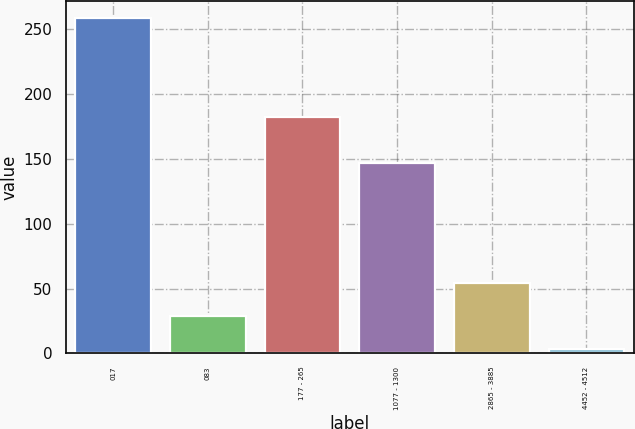<chart> <loc_0><loc_0><loc_500><loc_500><bar_chart><fcel>017<fcel>083<fcel>177 - 265<fcel>1077 - 1300<fcel>2865 - 3885<fcel>4452 - 4512<nl><fcel>259<fcel>28.6<fcel>182<fcel>147<fcel>54.2<fcel>3<nl></chart> 